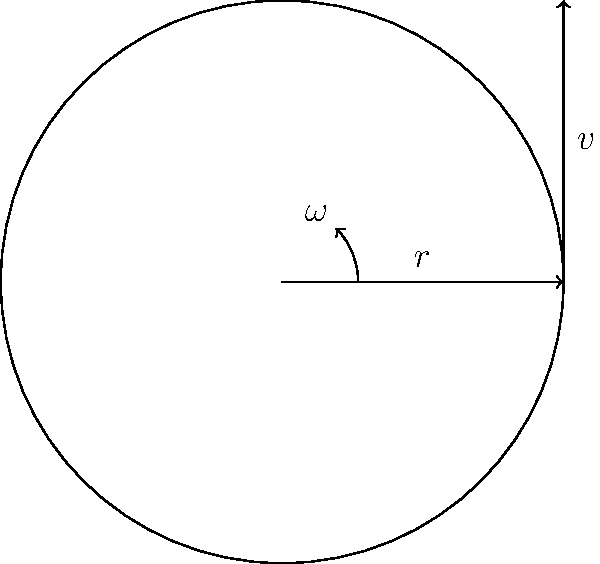A baseball pitcher is analyzing the rotational mechanics of their curveball. The ball has a radius of 3.7 cm and is spinning at 2000 radians per second. Using the circular motion diagram provided, calculate the linear velocity of a point on the surface of the baseball. To solve this problem, we'll use the relationship between linear velocity, angular velocity, and radius in circular motion. The steps are as follows:

1) The formula relating linear velocity ($v$), angular velocity ($\omega$), and radius ($r$) is:

   $v = r \omega$

2) We are given:
   - Radius ($r$) = 3.7 cm = 0.037 m
   - Angular velocity ($\omega$) = 2000 rad/s

3) Substituting these values into the equation:

   $v = 0.037 \text{ m} \times 2000 \text{ rad/s}$

4) Calculating:

   $v = 74 \text{ m/s}$

5) Converting to km/h for a more relatable speed:

   $74 \text{ m/s} \times \frac{3600 \text{ s}}{1 \text{ h}} \times \frac{1 \text{ km}}{1000 \text{ m}} = 266.4 \text{ km/h}$

Thus, a point on the surface of the baseball is moving at a linear velocity of 74 m/s or approximately 266.4 km/h.
Answer: 74 m/s or 266.4 km/h 